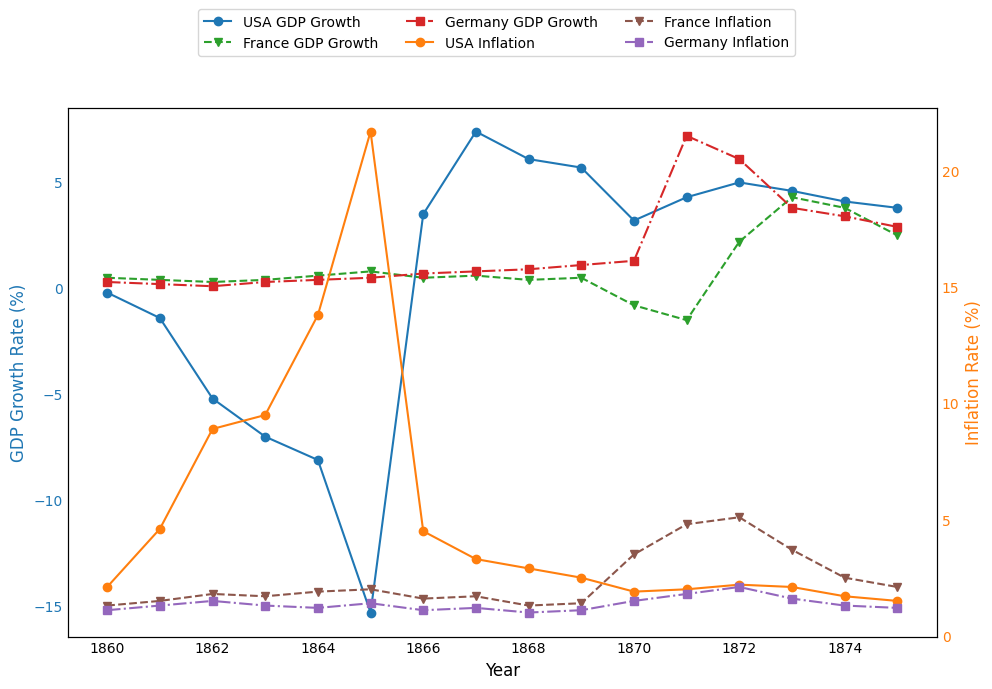Which country had the most significant drop in GDP growth during the American Civil War? The American Civil War lasted from 1861 to 1865. By comparing the GDP growth rates for the USA during this period, the largest drop can be seen in 1865 with -15.3%.
Answer: USA, 1865 What was the USA's inflation rate in the year when its GDP growth rate was the lowest during the Civil War? The USA's lowest GDP growth rate during the Civil War occurred in 1865 at -15.3%. For this year, the inflation rate was 21.7%.
Answer: 21.7% Compare the inflation rates of the USA and France in 1872. For 1872, the USA's inflation rate was 2.2%, and France's inflation rate was 5.1%. Comparing these, France had a higher inflation rate than the USA.
Answer: France What was the average GDP growth rate for Germany from 1860 to 1875? The GDP growth rates for Germany from 1860 to 1875 are 0.3, 0.2, 0.1, 0.3, 0.4, 0.5, 0.7, 0.8, 0.9, 1.1, 1.3, 7.2, 6.1, 3.8, 3.4, and 2.9. Summing these up gives 30.2%. Dividing by the number of years (16) gives an average of approximately 1.8875%.
Answer: 1.89% How did the GDP growth rates of France and Germany compare in 1871, the year after the Franco-Prussian war ended? In 1871, France had a GDP growth rate of -1.5%, while Germany had a GDP growth rate of 7.2%. Comparing these, Germany's GDP growth rate was much higher than France's.
Answer: Germany What is the relationship between the USA's GDP growth rate and inflation in 1866? In 1866, the USA's GDP growth rate was 3.5%, and the inflation rate was 4.5%. Understanding the relationship involves noting that positive GDP growth followed by reduced inflation rates from the previous year.
Answer: Positive GDP growth rate, reduced inflation Which country experienced the highest inflation rate, and in what year? The highest inflation rate occurred in the USA in 1865 at 21.7%.
Answer: USA, 1865 How did Germany's GDP growth rate change from 1870 to 1871? In 1870, Germany's GDP growth rate was 1.3%, and in 1871, it jumped to 7.2%. This represents a considerable increase of 5.9 percentage points.
Answer: Increased by 5.9% What was the difference in the GDP growth rates between USA and France in 1865? In 1865, the USA had a GDP growth rate of -15.3% and France had a growth rate of 0.8%. The difference would be -15.3% - 0.8% = -16.1%.
Answer: -16.1% Did France experience any year with a negative GDP growth rate after the Franco-Prussian War ended? Yes, after the Franco-Prussian War ended in 1871, France had a negative GDP growth rate of -1.5% in 1871.
Answer: Yes 